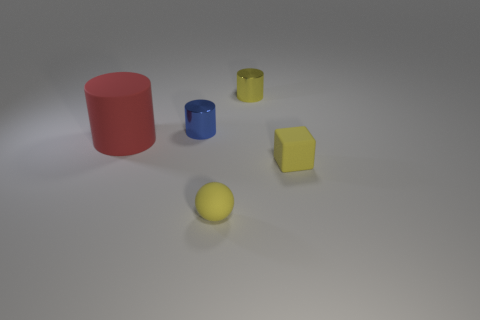There is a yellow object that is behind the big matte thing; is it the same shape as the red thing on the left side of the small cube?
Provide a short and direct response. Yes. There is a small object that is to the right of the metal cylinder behind the small metal cylinder that is to the left of the yellow metallic thing; what is it made of?
Give a very brief answer. Rubber. There is a blue object that is the same size as the sphere; what is its shape?
Provide a short and direct response. Cylinder. Is there a cylinder of the same color as the matte ball?
Give a very brief answer. Yes. How big is the yellow sphere?
Offer a terse response. Small. Does the small yellow ball have the same material as the blue thing?
Provide a succinct answer. No. There is a metal object that is on the left side of the yellow object behind the red matte cylinder; how many small blue metal objects are in front of it?
Offer a very short reply. 0. There is a small rubber object that is behind the matte ball; what is its shape?
Offer a very short reply. Cube. How many other things are made of the same material as the small blue object?
Your answer should be compact. 1. Does the tiny rubber block have the same color as the small rubber sphere?
Your answer should be compact. Yes. 